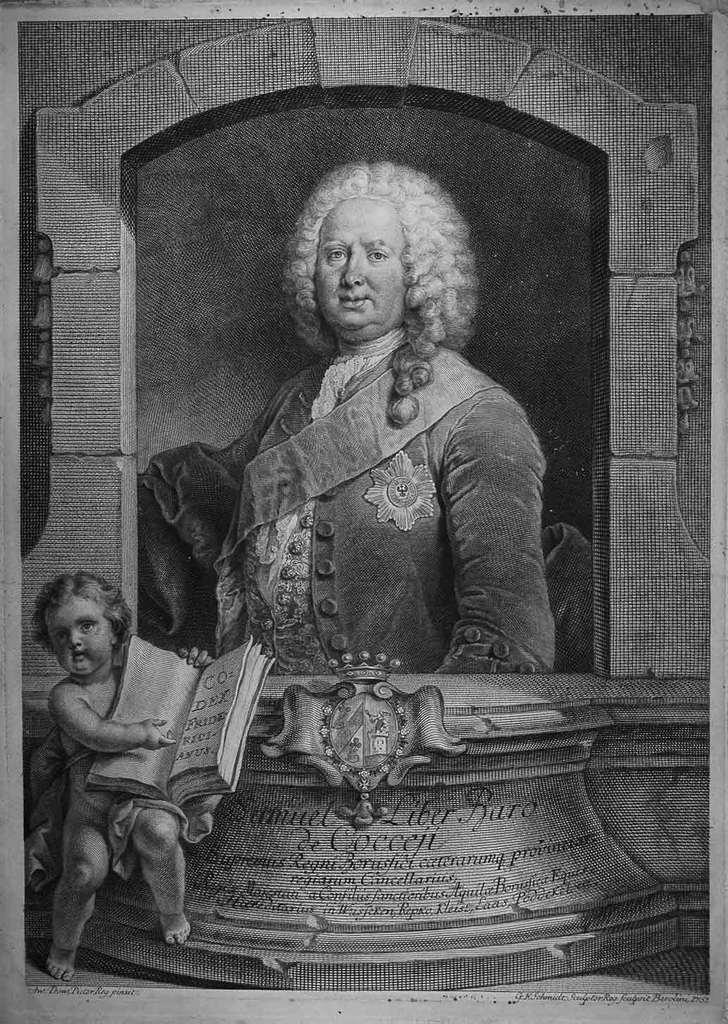What can be seen on the wall in the image? There is a picture of a person on the wall. What is the kid on the left side of the image doing? The kid is holding a book on the left side of the image. Can you describe the writing in the image? There is writing on a platform in the image. How many toes can be seen on the person in the picture on the wall? There is no information about the person's toes in the image, as it only shows a picture of a person on the wall. What type of guide is present in the image? There is no guide present in the image; it features a picture of a person on the wall, a kid holding a book, and writing on a platform. 